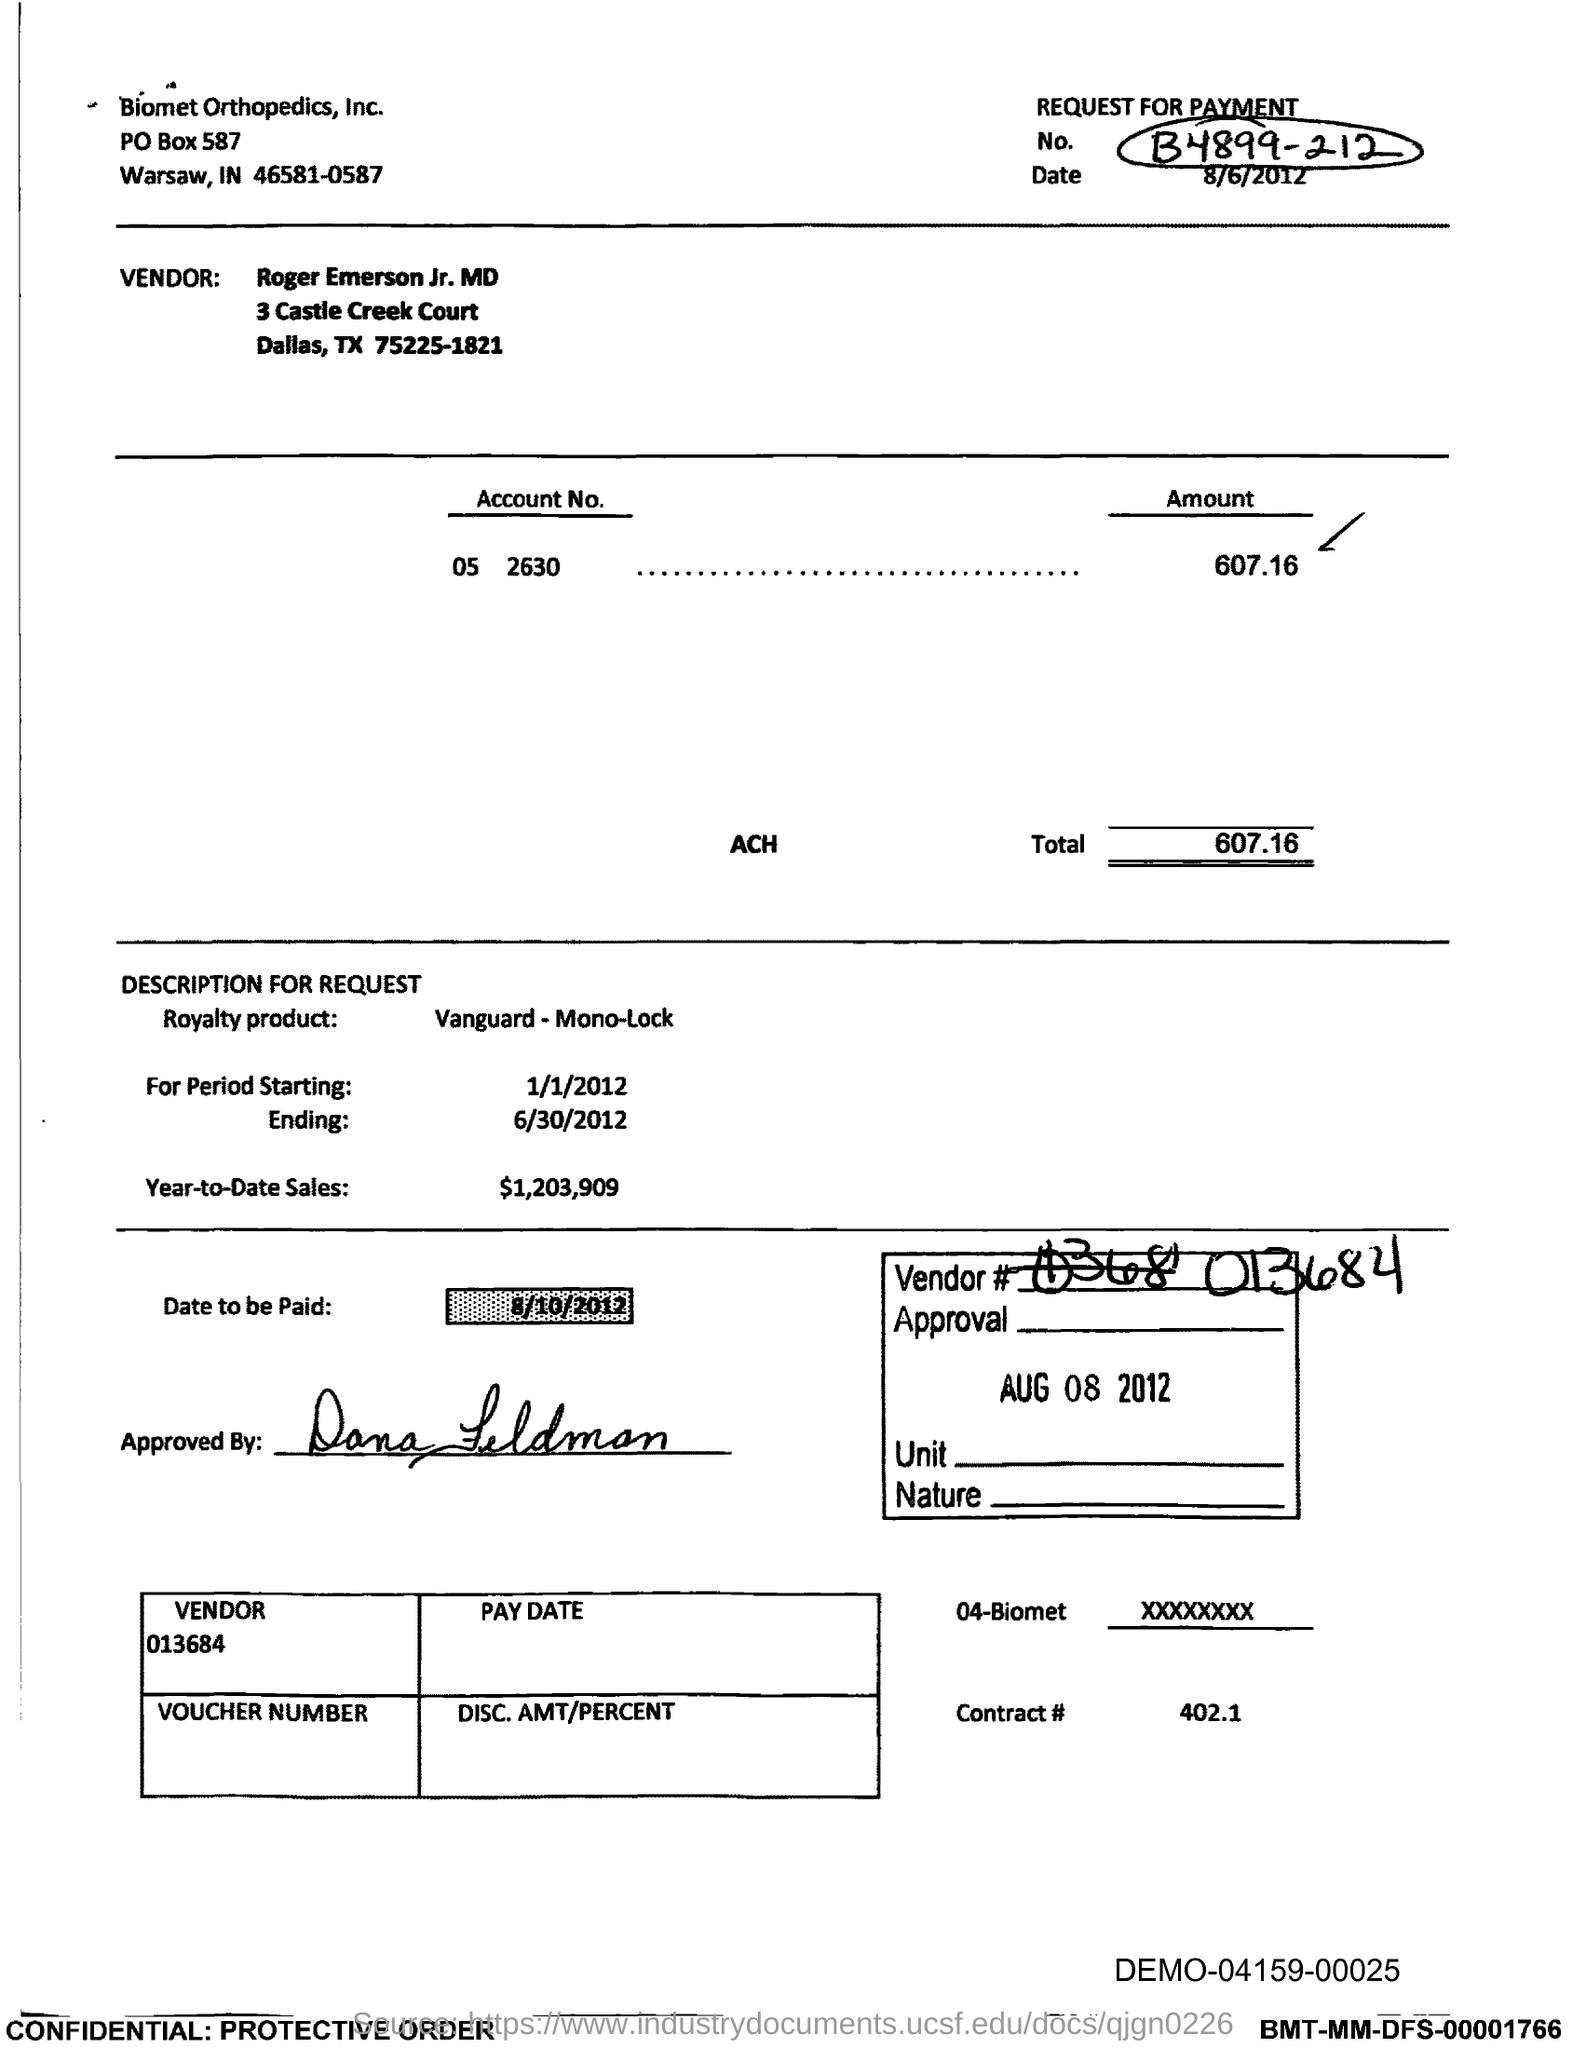What is the date to be paid mentioned in the document?
Make the answer very short. 8/10/2012. What is the Year-to-Date-Sales mentioned in the document?
Provide a short and direct response. 1,203,909. What is the Total?
Your answer should be very brief. 607.16. What is the date mentioned in the box?
Offer a terse response. Aug 08 2012. 